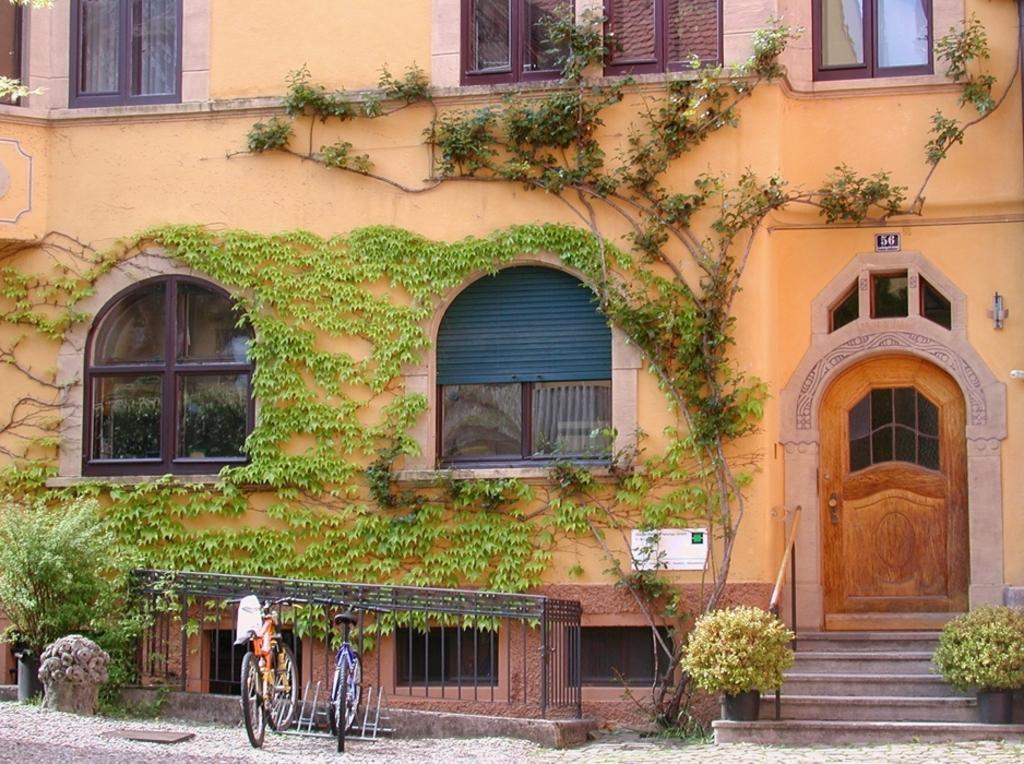Please provide a concise description of this image. In this image we can see front view of a building which is in orange color. The door of the building is in brown color. In front of doors stairs are there and plants are kept. To the right side of the building one grille is there, in front of the grille two bicycles are parked. 